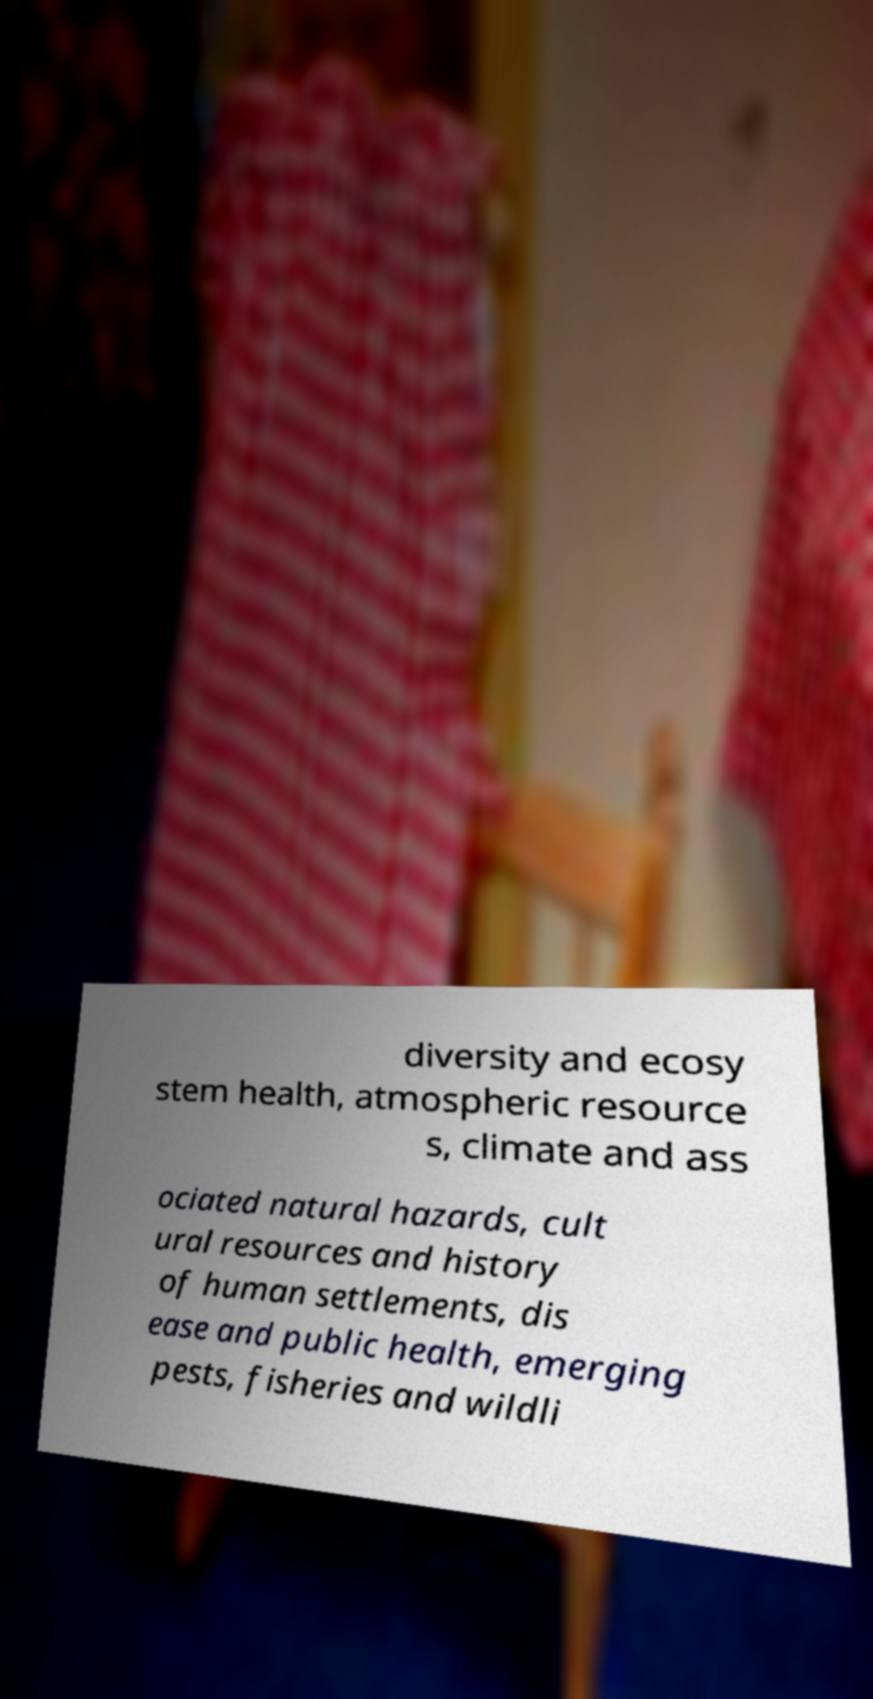Please identify and transcribe the text found in this image. diversity and ecosy stem health, atmospheric resource s, climate and ass ociated natural hazards, cult ural resources and history of human settlements, dis ease and public health, emerging pests, fisheries and wildli 